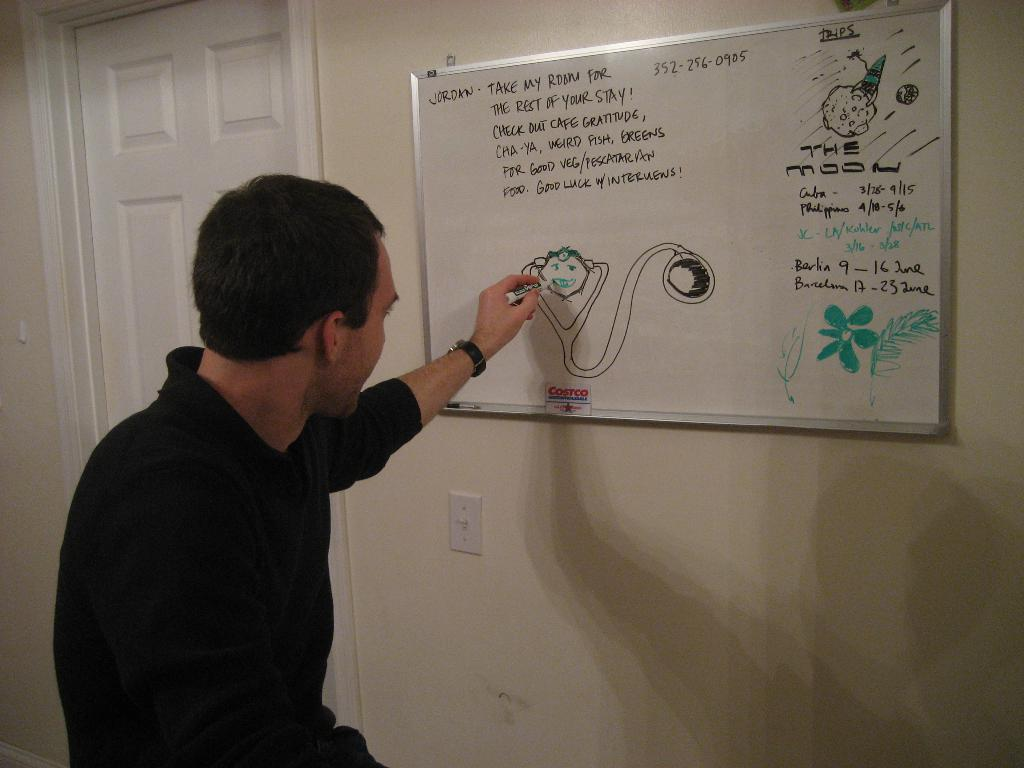<image>
Give a short and clear explanation of the subsequent image. The word Barcelona is on the white board 